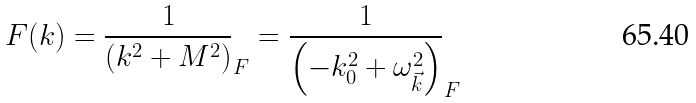<formula> <loc_0><loc_0><loc_500><loc_500>F ( k ) = \frac { 1 } { \left ( k ^ { 2 } + M ^ { 2 } \right ) } _ { F } = \frac { 1 } { \left ( - k _ { 0 } ^ { 2 } + { \omega } _ { \vec { k } } ^ { 2 } \right ) } _ { F }</formula> 